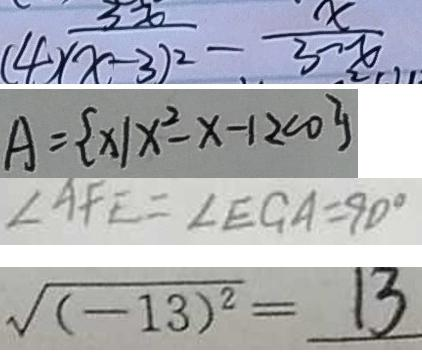<formula> <loc_0><loc_0><loc_500><loc_500>\frac { 3 x } { ( 4 ) ( x - 3 ) ^ { 2 } } - \frac { x } { 3 - x } 
 A = \{ x \vert x ^ { 2 } - x - 1 2 < 0 \} 
 \angle A F E = \angle E G A = 9 0 ^ { \circ } 
 \sqrt { ( - 1 3 ) ^ { 2 } } = 1 3</formula> 